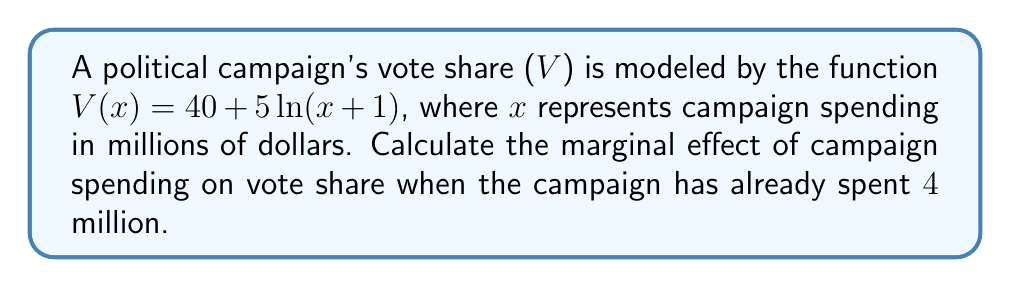Can you answer this question? To determine the marginal effect of campaign spending on vote share, we need to find the derivative of the vote share function $V(x)$ and evaluate it at $x = 4$.

Step 1: Find the derivative of $V(x)$.
$$\frac{d}{dx}V(x) = \frac{d}{dx}[40 + 5\ln(x+1)]$$
$$V'(x) = 5 \cdot \frac{d}{dx}[\ln(x+1)]$$
$$V'(x) = 5 \cdot \frac{1}{x+1}$$

Step 2: Evaluate the derivative at $x = 4$.
$$V'(4) = 5 \cdot \frac{1}{4+1} = 5 \cdot \frac{1}{5} = 1$$

The marginal effect is 1 percentage point per million dollars spent when the campaign has already spent $4 million.

This means that for each additional million dollars spent on the campaign (starting from $4 million), the vote share is expected to increase by approximately 1 percentage point.
Answer: $1$ percentage point per million dollars 